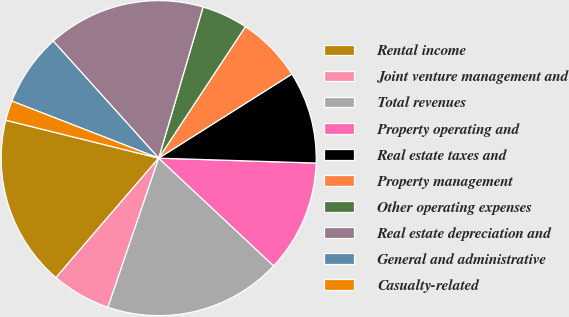Convert chart to OTSL. <chart><loc_0><loc_0><loc_500><loc_500><pie_chart><fcel>Rental income<fcel>Joint venture management and<fcel>Total revenues<fcel>Property operating and<fcel>Real estate taxes and<fcel>Property management<fcel>Other operating expenses<fcel>Real estate depreciation and<fcel>General and administrative<fcel>Casualty-related<nl><fcel>17.57%<fcel>6.08%<fcel>18.24%<fcel>11.49%<fcel>9.46%<fcel>6.76%<fcel>4.73%<fcel>16.22%<fcel>7.43%<fcel>2.03%<nl></chart> 